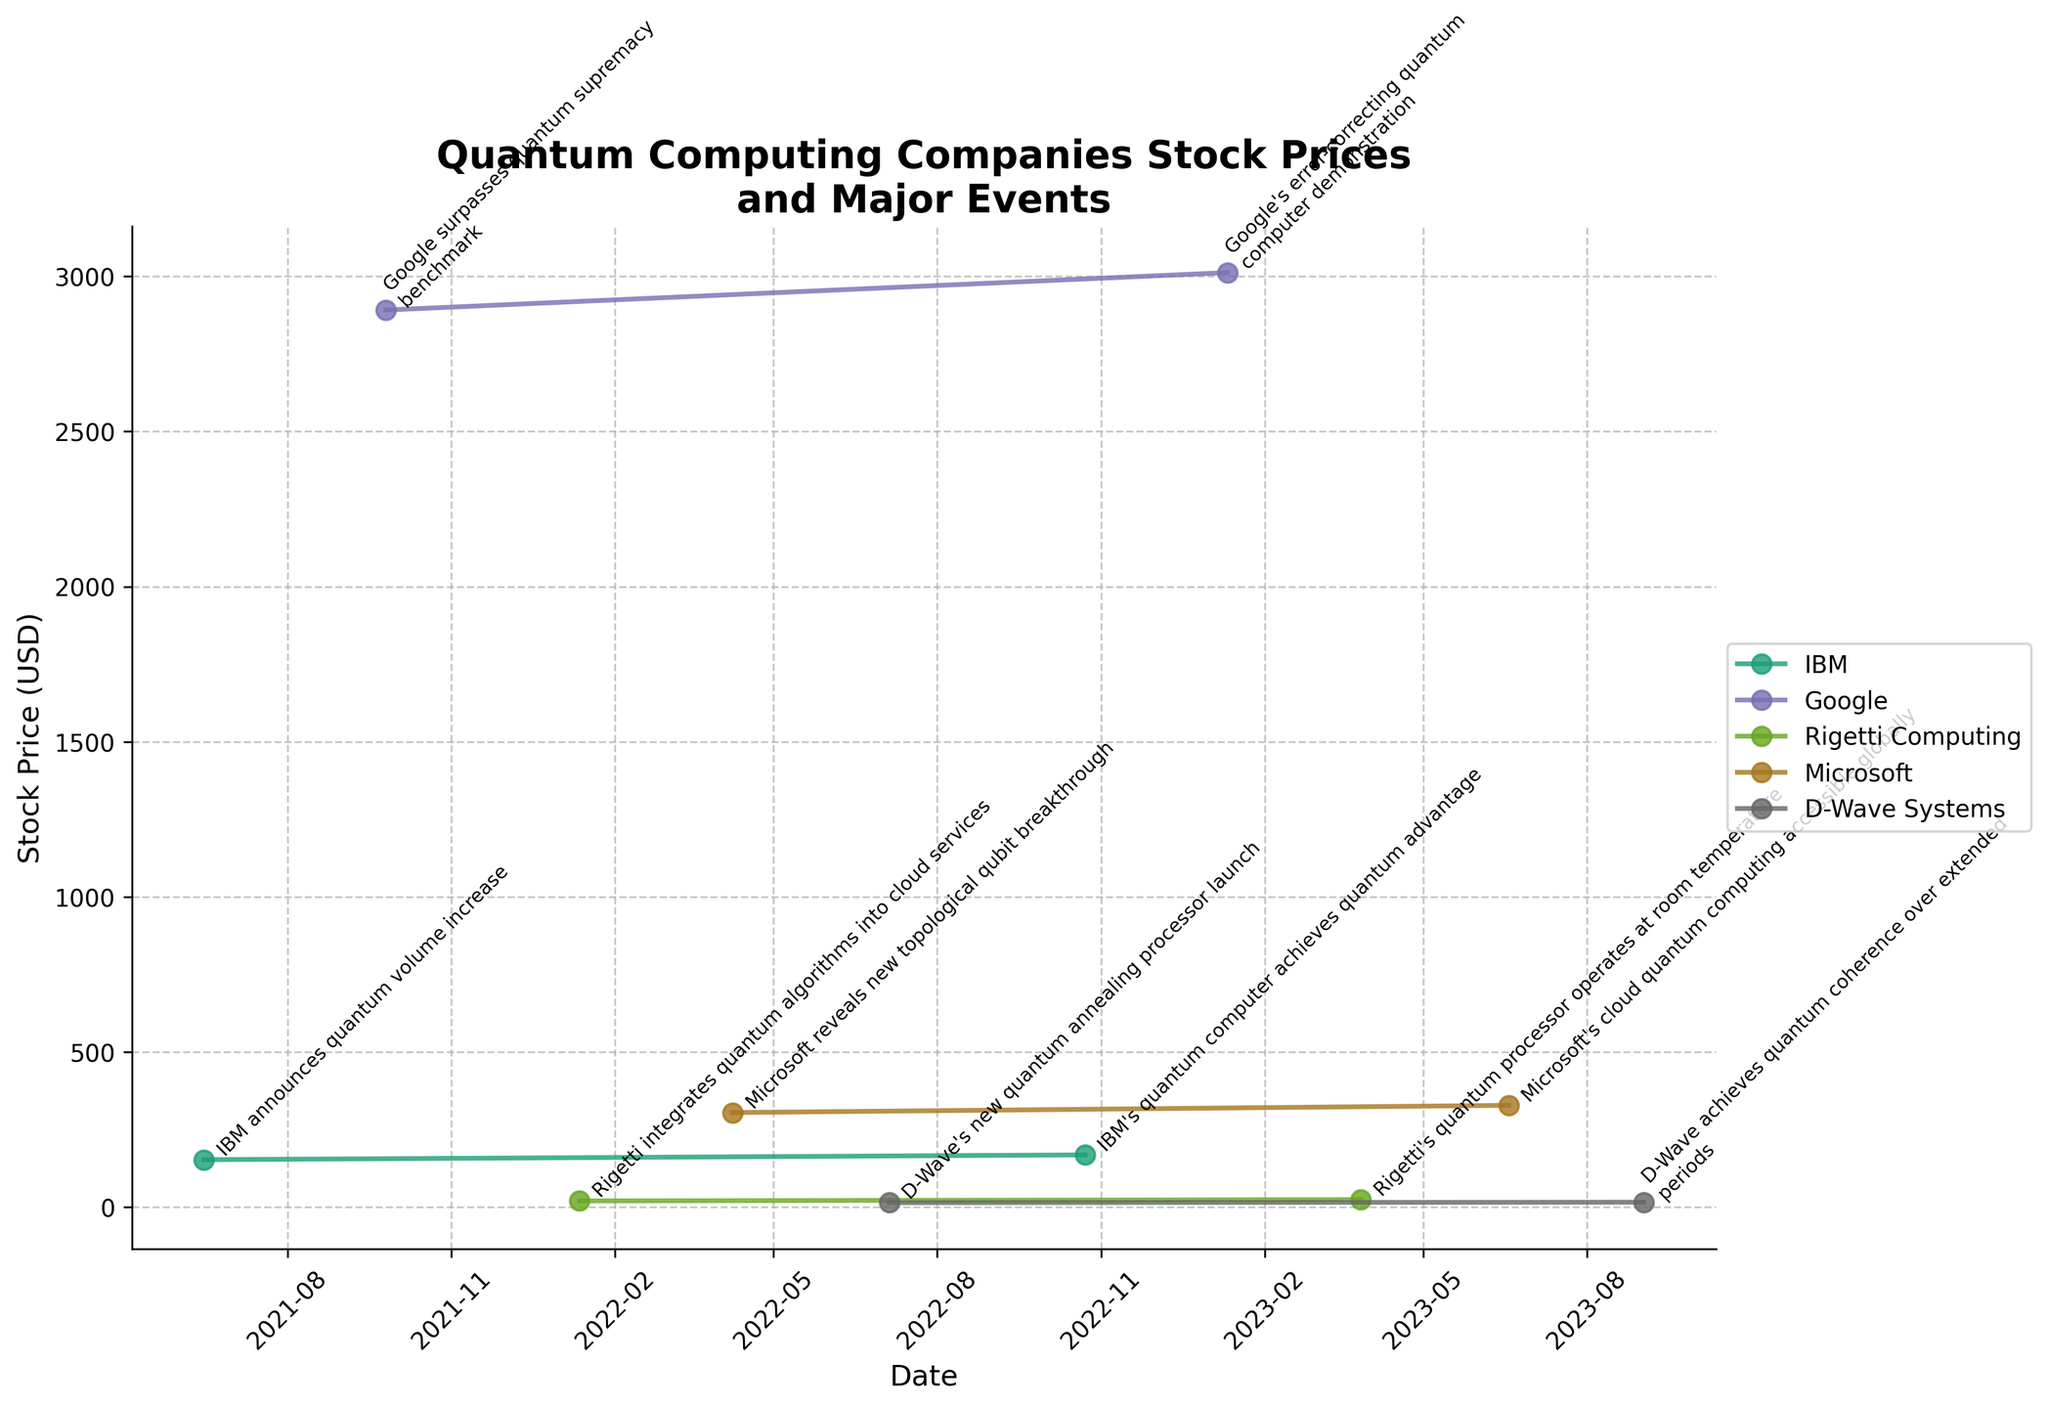what is the title of the plot? The title of the plot is located at the top and often gives a summary or an idea of what the plot is about. Referring to that part, we see the title is 'Quantum Computing Companies Stock Prices and Major Events'
Answer: Quantum Computing Companies Stock Prices and Major Events Which company announced a new topological qubit breakthrough in April 2022? By looking at the annotated events in April 2022, we find that Microsoft made the announcement. This information is identified by the label on the plot around the date.
Answer: Microsoft What's the general trend for Google's stock price between the two given dates in the dataset? To identify the trend, follow Google's stock price line from 2021-09-25 to 2023-01-11. Observing the data points shows an initial stock price of $2891.55 gradually increasing to $3012.33.
Answer: Upward trend Which company's stock price increased the most between their two given events? By comparing the stock price changes between events for each company: IBM (152.30 to 167.80), Google (2891.55 to 3012.33), Rigetti (19.45 to 23.67), Microsoft (304.21 to 327.55), and D-Wave (13.70 to 15.23), we see that Google had the largest increase. The increase for Google is (3012.33 - 2891.55 = 120.78).
Answer: Google How many companies experienced a stock price increase between their two given events? By assessing the stock price at the two given events for each company, we notice the following increases: IBM (from 152.30 to 167.80), Google (from 2891.55 to 3012.33), Rigetti (from 19.45 to 23.67), Microsoft (from 304.21 to 327.55), D-Wave (from 13.70 to 15.23), with all companies showing an increase. Thus, the answer is five.
Answer: Five What major event corresponds with the highest stock price for Google? Looking at Google's annotated events and their associated stock prices, the highest stock price for Google is at $3012.33 corresponding to the event on 2023-01-11, "Google's error-correcting quantum computer demonstration."
Answer: Google's error-correcting quantum computer demonstration Compare the stock price of IBM and Rigetti Computing on 2021-06-15 and 2022-01-12 respectively. Which is higher? On 2021-06-15, IBM's stock price is 152.30, and on 2022-01-12, Rigetti Computing's stock price is 19.45. Comparing 152.30 and 19.45, we see IBM's stock price is higher.
Answer: IBM What's the difference in stock prices for Microsoft between July 2022 and June 2023 events? For July 2022 (stock price = 304.21) and June 2023 (stock price = 327.55), calculate the difference: 327.55 - 304.21 = 23.34.
Answer: 23.34 